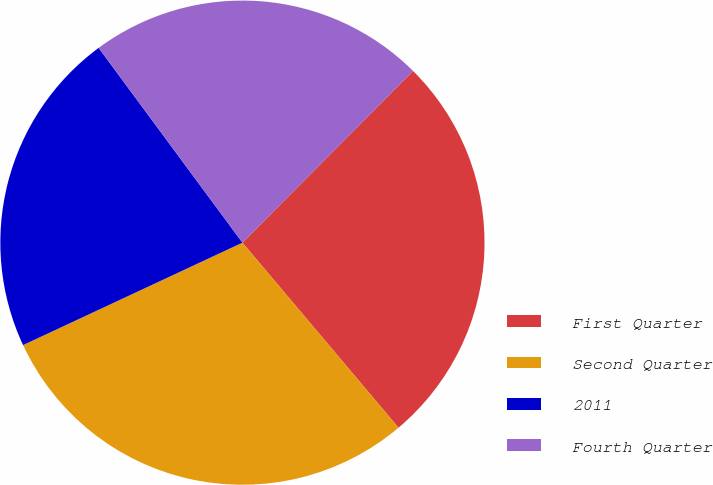Convert chart. <chart><loc_0><loc_0><loc_500><loc_500><pie_chart><fcel>First Quarter<fcel>Second Quarter<fcel>2011<fcel>Fourth Quarter<nl><fcel>26.4%<fcel>29.2%<fcel>21.83%<fcel>22.57%<nl></chart> 